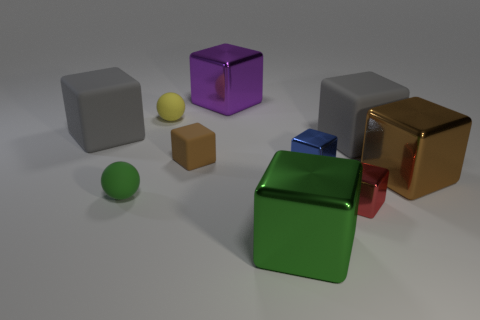Subtract all blue blocks. How many blocks are left? 7 Subtract all green spheres. How many spheres are left? 1 Subtract all spheres. How many objects are left? 8 Subtract 4 blocks. How many blocks are left? 4 Subtract all gray spheres. How many gray blocks are left? 2 Subtract all brown things. Subtract all green things. How many objects are left? 6 Add 7 small red blocks. How many small red blocks are left? 8 Add 7 green matte objects. How many green matte objects exist? 8 Subtract 1 green spheres. How many objects are left? 9 Subtract all brown cubes. Subtract all cyan cylinders. How many cubes are left? 6 